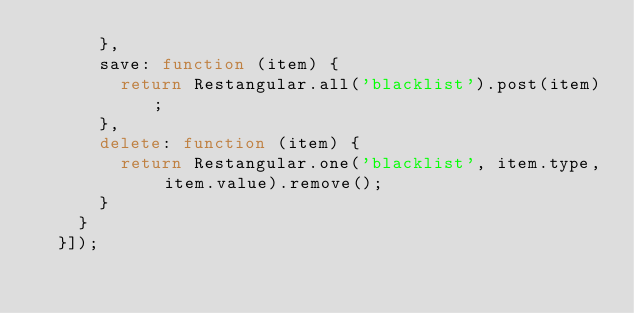<code> <loc_0><loc_0><loc_500><loc_500><_JavaScript_>      },
      save: function (item) {
        return Restangular.all('blacklist').post(item);
      },
      delete: function (item) {
        return Restangular.one('blacklist', item.type, item.value).remove();
      }
    }
  }]);
</code> 